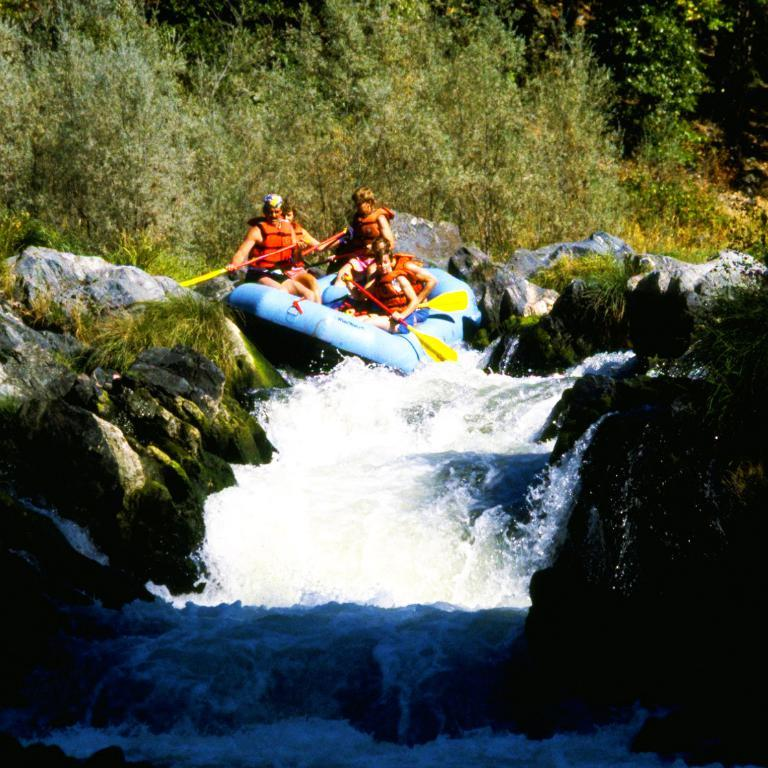What type of vehicle is in the image? There is an inflatable boat in the image. How many people are on the boat? There are five persons on the boat. Where is the boat located? The boat is sailing on a river. What can be seen on either side of the river? There are stones on either side of the river. What is visible in the background of the image? There are trees in the background of the image. What type of flame can be seen on the boat in the image? There is no flame present on the boat or in the image. What causes a shock to the people on the boat in the image? There is no indication of a shock or any electrical hazard in the image. 